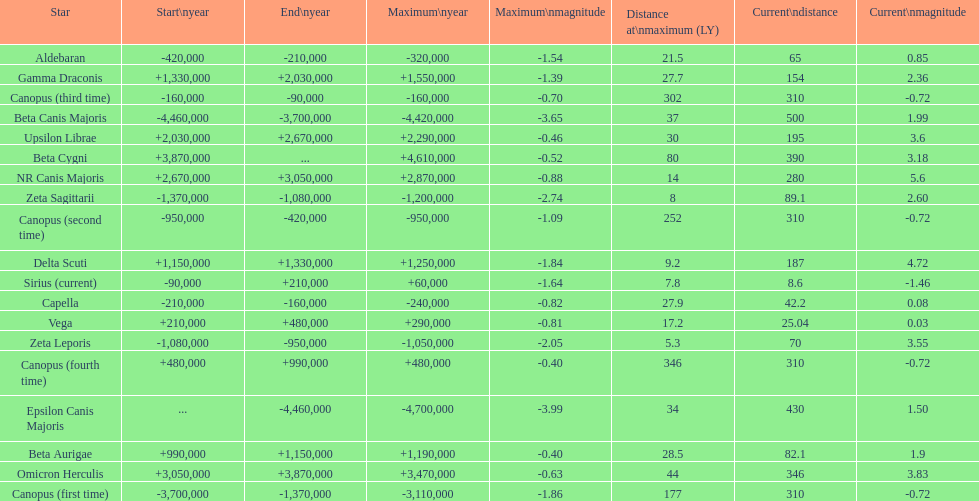How many stars have a current magnitude of at least 1.0? 11. 